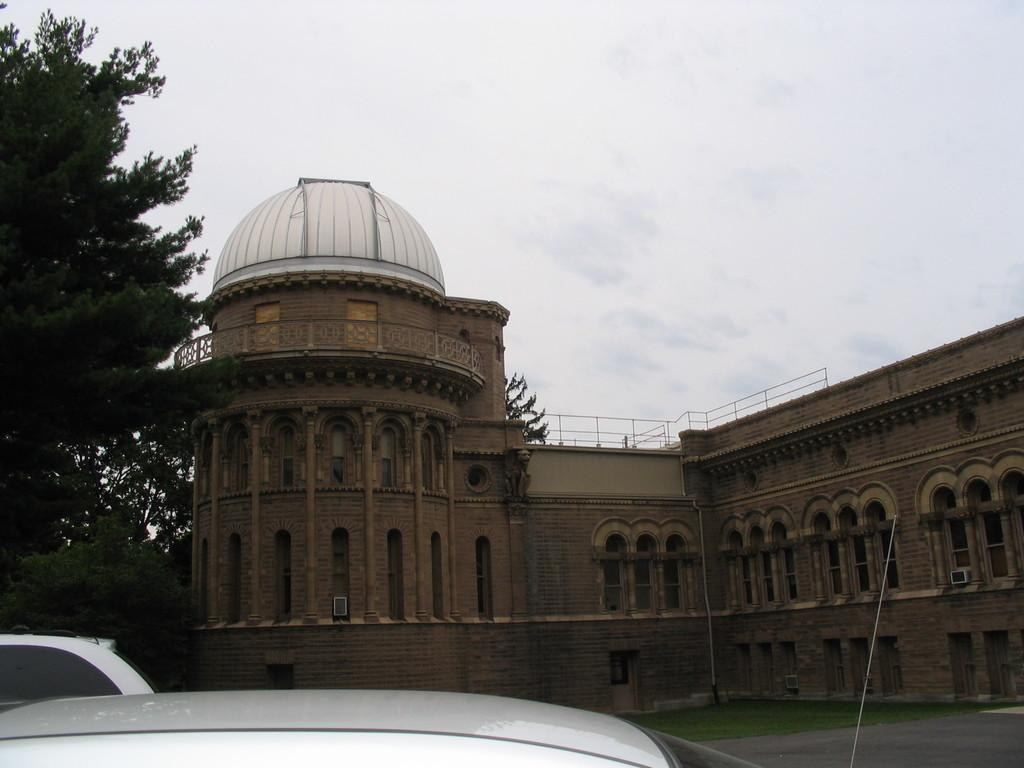What is the main structure in the center of the image? There is a building in the center of the image. What type of transportation can be seen on the road at the bottom of the image? Cars are visible on the road at the bottom of the image. What can be seen in the background of the image? There are trees and the sky visible in the background of the image. What decision is being made by the hill in the image? There is no hill present in the image, and therefore no decision can be made by it. 